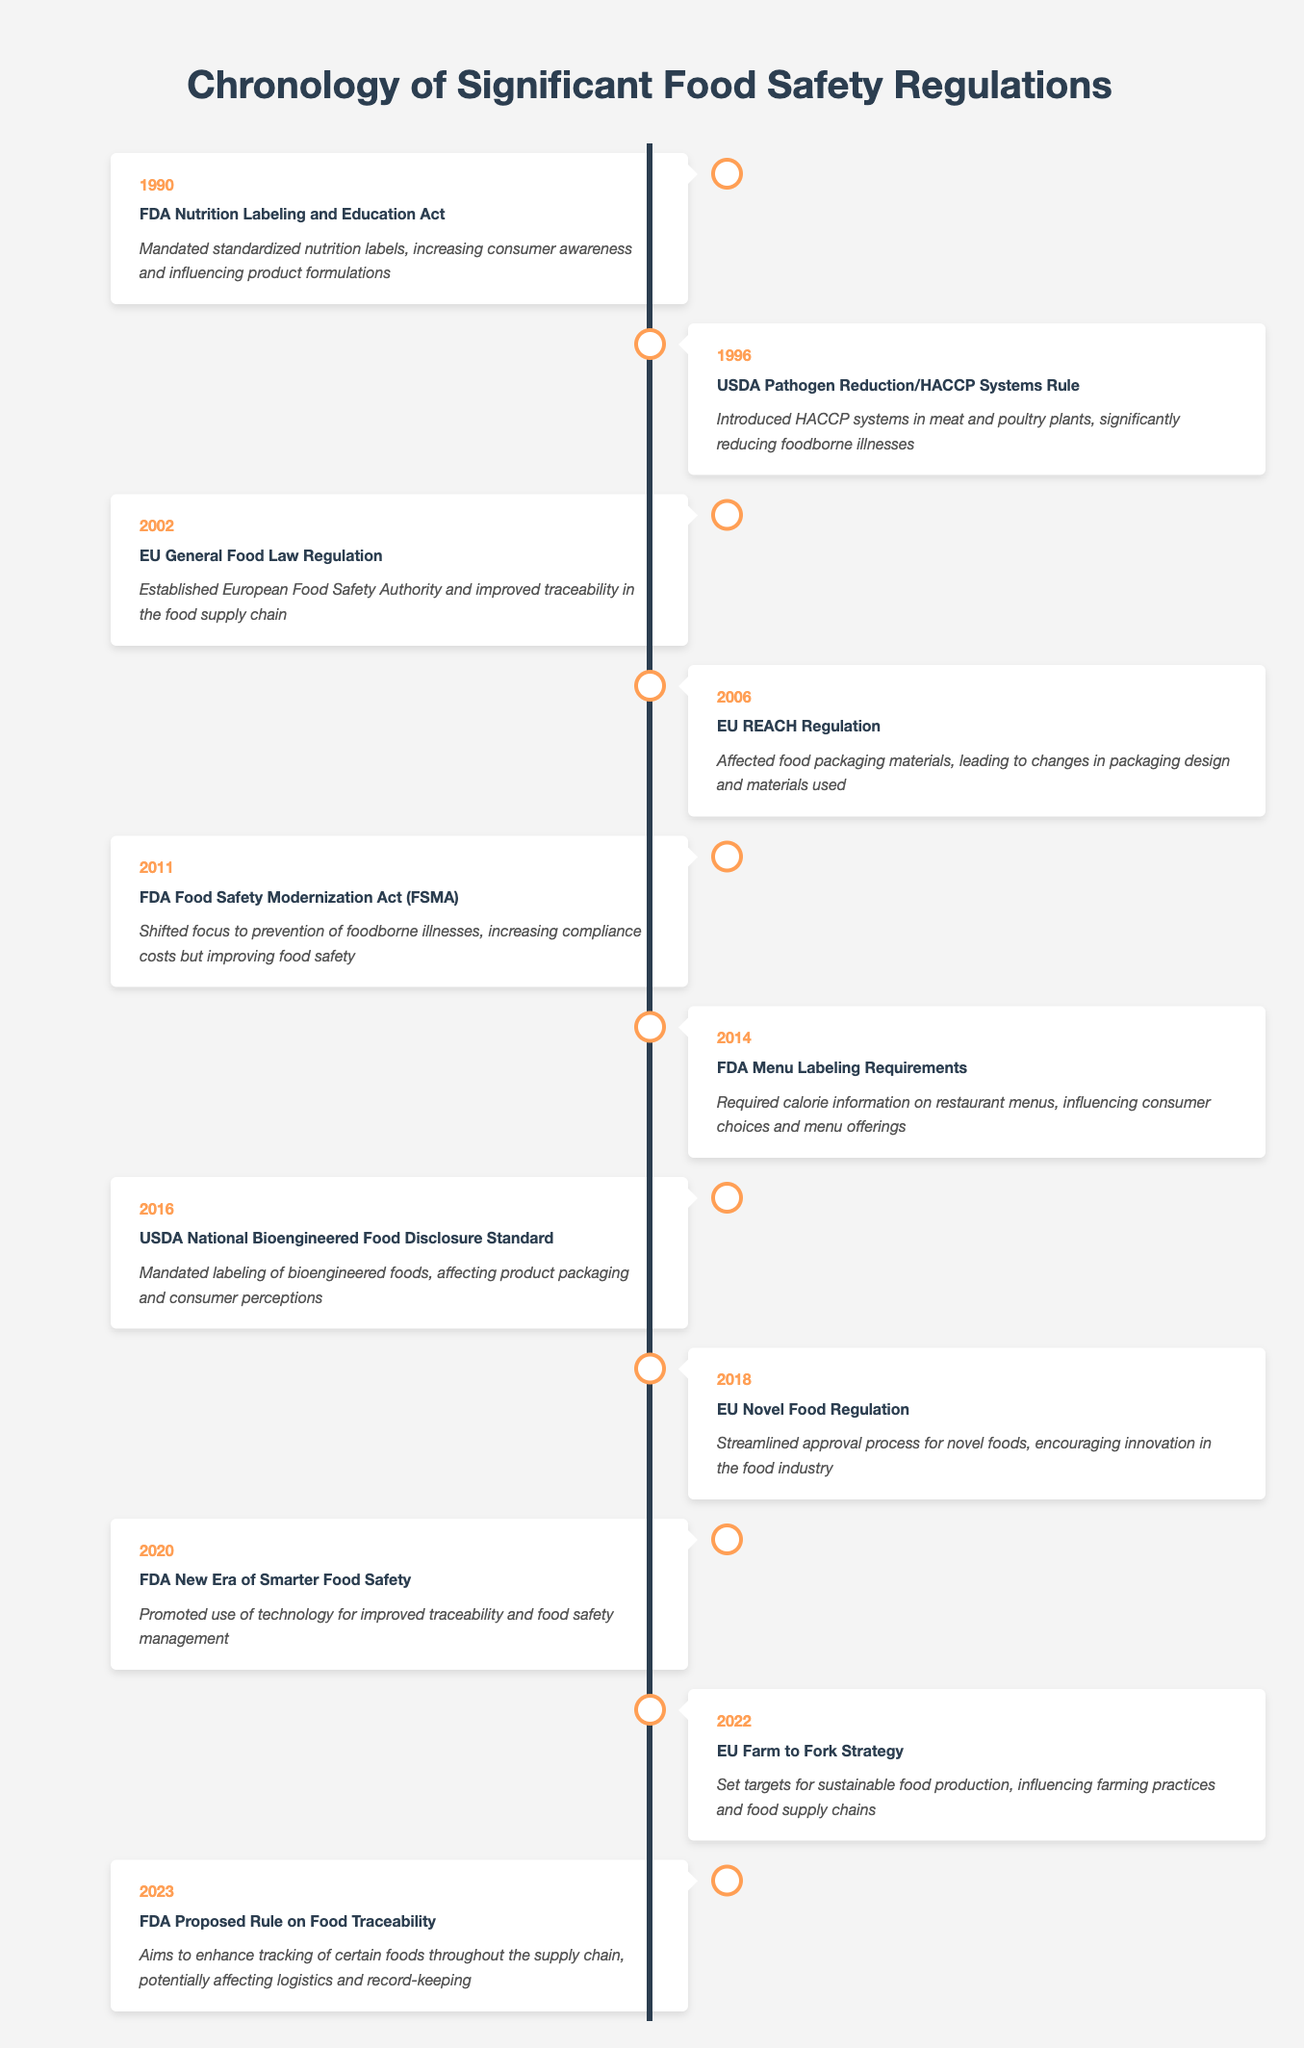What significant regulation was enacted in 1996? The table shows that in 1996, the USDA Pathogen Reduction/HACCP Systems Rule was enacted.
Answer: USDA Pathogen Reduction/HACCP Systems Rule What impact did the FDA Food Safety Modernization Act have on compliance costs? The table indicates that the act increased compliance costs while improving food safety.
Answer: Increased compliance costs Which event aimed to enhance tracking of foods throughout the supply chain? According to the table, the FDA Proposed Rule on Food Traceability in 2023 aimed to enhance tracking of certain foods.
Answer: FDA Proposed Rule on Food Traceability How many regulations were established between 2000 and 2010? From the table, the regulations established during this period are the EU General Food Law Regulation (2002), FDA Food Safety Modernization Act (2011), and EU Novel Food Regulation (2018). Therefore, there were 3 significant regulations.
Answer: 3 Did the EU Farm to Fork Strategy influence farming practices? The table states that the EU Farm to Fork Strategy (2022) set targets for sustainable food production, which indicates it did influence farming practices.
Answer: Yes Which years saw the introduction of regulations focused on labeling? The table shows that two regulations focused on labeling were introduced: FDA Nutrition Labeling and Education Act (1990) and FDA Menu Labeling Requirements (2014). Thus, 1990 and 2014 are the years with labeling regulations.
Answer: 1990, 2014 What was the main effect of the EU Novel Food Regulation? The table clarifies that the main effect was to streamline the approval process for novel foods, which encouraged innovation in the food industry.
Answer: Streamlined approval process Which regulation had the earliest impact on consumer awareness through nutrition labels? According to the table, the FDA Nutrition Labeling and Education Act in 1990 was the regulation that had the earliest impact on consumer awareness through standardized nutrition labels.
Answer: FDA Nutrition Labeling and Education Act What is the latest food safety regulation listed in the timeline? Based on the table, the latest food safety regulation listed is the FDA Proposed Rule on Food Traceability from 2023.
Answer: FDA Proposed Rule on Food Traceability 